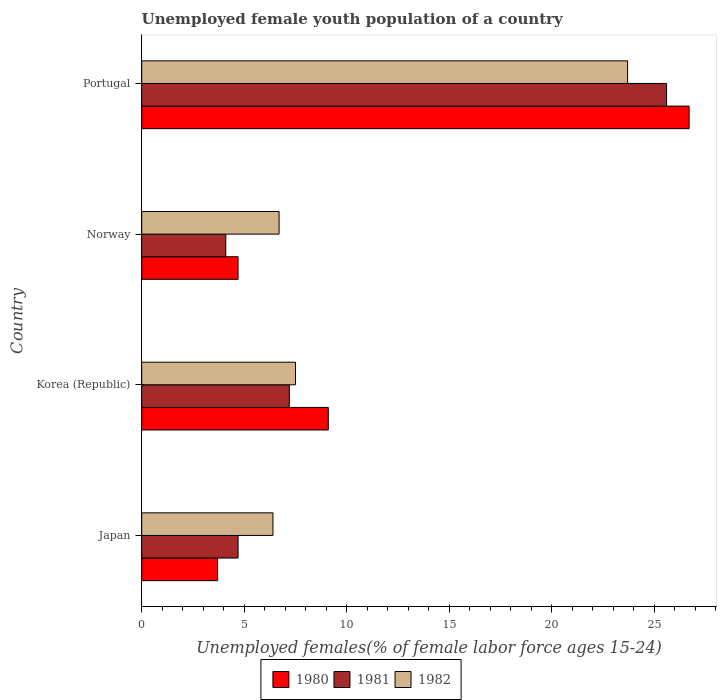How many different coloured bars are there?
Your response must be concise. 3. How many groups of bars are there?
Provide a succinct answer. 4. Are the number of bars on each tick of the Y-axis equal?
Make the answer very short. Yes. How many bars are there on the 2nd tick from the top?
Offer a very short reply. 3. How many bars are there on the 3rd tick from the bottom?
Ensure brevity in your answer.  3. What is the label of the 3rd group of bars from the top?
Give a very brief answer. Korea (Republic). In how many cases, is the number of bars for a given country not equal to the number of legend labels?
Give a very brief answer. 0. What is the percentage of unemployed female youth population in 1982 in Norway?
Your response must be concise. 6.7. Across all countries, what is the maximum percentage of unemployed female youth population in 1980?
Offer a very short reply. 26.7. Across all countries, what is the minimum percentage of unemployed female youth population in 1982?
Offer a very short reply. 6.4. In which country was the percentage of unemployed female youth population in 1980 maximum?
Keep it short and to the point. Portugal. What is the total percentage of unemployed female youth population in 1980 in the graph?
Give a very brief answer. 44.2. What is the difference between the percentage of unemployed female youth population in 1980 in Japan and that in Portugal?
Offer a terse response. -23. What is the difference between the percentage of unemployed female youth population in 1982 in Japan and the percentage of unemployed female youth population in 1980 in Norway?
Give a very brief answer. 1.7. What is the average percentage of unemployed female youth population in 1980 per country?
Provide a short and direct response. 11.05. What is the difference between the percentage of unemployed female youth population in 1981 and percentage of unemployed female youth population in 1980 in Japan?
Make the answer very short. 1. In how many countries, is the percentage of unemployed female youth population in 1980 greater than 5 %?
Provide a succinct answer. 2. What is the ratio of the percentage of unemployed female youth population in 1980 in Korea (Republic) to that in Portugal?
Keep it short and to the point. 0.34. Is the percentage of unemployed female youth population in 1982 in Korea (Republic) less than that in Portugal?
Provide a short and direct response. Yes. Is the difference between the percentage of unemployed female youth population in 1981 in Japan and Norway greater than the difference between the percentage of unemployed female youth population in 1980 in Japan and Norway?
Offer a terse response. Yes. What is the difference between the highest and the second highest percentage of unemployed female youth population in 1982?
Your answer should be very brief. 16.2. What is the difference between the highest and the lowest percentage of unemployed female youth population in 1980?
Offer a terse response. 23. Is the sum of the percentage of unemployed female youth population in 1981 in Norway and Portugal greater than the maximum percentage of unemployed female youth population in 1980 across all countries?
Offer a very short reply. Yes. What does the 3rd bar from the bottom in Korea (Republic) represents?
Your answer should be compact. 1982. How many countries are there in the graph?
Give a very brief answer. 4. Does the graph contain grids?
Provide a short and direct response. No. What is the title of the graph?
Provide a succinct answer. Unemployed female youth population of a country. Does "1975" appear as one of the legend labels in the graph?
Provide a succinct answer. No. What is the label or title of the X-axis?
Offer a terse response. Unemployed females(% of female labor force ages 15-24). What is the Unemployed females(% of female labor force ages 15-24) in 1980 in Japan?
Your response must be concise. 3.7. What is the Unemployed females(% of female labor force ages 15-24) of 1981 in Japan?
Offer a very short reply. 4.7. What is the Unemployed females(% of female labor force ages 15-24) in 1982 in Japan?
Your response must be concise. 6.4. What is the Unemployed females(% of female labor force ages 15-24) of 1980 in Korea (Republic)?
Make the answer very short. 9.1. What is the Unemployed females(% of female labor force ages 15-24) in 1981 in Korea (Republic)?
Your answer should be compact. 7.2. What is the Unemployed females(% of female labor force ages 15-24) in 1982 in Korea (Republic)?
Your response must be concise. 7.5. What is the Unemployed females(% of female labor force ages 15-24) of 1980 in Norway?
Your answer should be compact. 4.7. What is the Unemployed females(% of female labor force ages 15-24) in 1981 in Norway?
Provide a short and direct response. 4.1. What is the Unemployed females(% of female labor force ages 15-24) of 1982 in Norway?
Provide a short and direct response. 6.7. What is the Unemployed females(% of female labor force ages 15-24) in 1980 in Portugal?
Your response must be concise. 26.7. What is the Unemployed females(% of female labor force ages 15-24) in 1981 in Portugal?
Offer a terse response. 25.6. What is the Unemployed females(% of female labor force ages 15-24) of 1982 in Portugal?
Ensure brevity in your answer.  23.7. Across all countries, what is the maximum Unemployed females(% of female labor force ages 15-24) of 1980?
Provide a short and direct response. 26.7. Across all countries, what is the maximum Unemployed females(% of female labor force ages 15-24) in 1981?
Your answer should be very brief. 25.6. Across all countries, what is the maximum Unemployed females(% of female labor force ages 15-24) in 1982?
Your response must be concise. 23.7. Across all countries, what is the minimum Unemployed females(% of female labor force ages 15-24) of 1980?
Give a very brief answer. 3.7. Across all countries, what is the minimum Unemployed females(% of female labor force ages 15-24) in 1981?
Your response must be concise. 4.1. Across all countries, what is the minimum Unemployed females(% of female labor force ages 15-24) of 1982?
Provide a short and direct response. 6.4. What is the total Unemployed females(% of female labor force ages 15-24) of 1980 in the graph?
Offer a terse response. 44.2. What is the total Unemployed females(% of female labor force ages 15-24) in 1981 in the graph?
Your answer should be compact. 41.6. What is the total Unemployed females(% of female labor force ages 15-24) in 1982 in the graph?
Make the answer very short. 44.3. What is the difference between the Unemployed females(% of female labor force ages 15-24) of 1980 in Japan and that in Korea (Republic)?
Your response must be concise. -5.4. What is the difference between the Unemployed females(% of female labor force ages 15-24) of 1982 in Japan and that in Korea (Republic)?
Provide a short and direct response. -1.1. What is the difference between the Unemployed females(% of female labor force ages 15-24) in 1981 in Japan and that in Norway?
Keep it short and to the point. 0.6. What is the difference between the Unemployed females(% of female labor force ages 15-24) in 1981 in Japan and that in Portugal?
Offer a terse response. -20.9. What is the difference between the Unemployed females(% of female labor force ages 15-24) of 1982 in Japan and that in Portugal?
Keep it short and to the point. -17.3. What is the difference between the Unemployed females(% of female labor force ages 15-24) of 1980 in Korea (Republic) and that in Portugal?
Your answer should be very brief. -17.6. What is the difference between the Unemployed females(% of female labor force ages 15-24) in 1981 in Korea (Republic) and that in Portugal?
Provide a short and direct response. -18.4. What is the difference between the Unemployed females(% of female labor force ages 15-24) of 1982 in Korea (Republic) and that in Portugal?
Offer a very short reply. -16.2. What is the difference between the Unemployed females(% of female labor force ages 15-24) of 1980 in Norway and that in Portugal?
Provide a short and direct response. -22. What is the difference between the Unemployed females(% of female labor force ages 15-24) in 1981 in Norway and that in Portugal?
Make the answer very short. -21.5. What is the difference between the Unemployed females(% of female labor force ages 15-24) in 1982 in Norway and that in Portugal?
Ensure brevity in your answer.  -17. What is the difference between the Unemployed females(% of female labor force ages 15-24) in 1980 in Japan and the Unemployed females(% of female labor force ages 15-24) in 1982 in Korea (Republic)?
Offer a terse response. -3.8. What is the difference between the Unemployed females(% of female labor force ages 15-24) in 1981 in Japan and the Unemployed females(% of female labor force ages 15-24) in 1982 in Norway?
Offer a very short reply. -2. What is the difference between the Unemployed females(% of female labor force ages 15-24) of 1980 in Japan and the Unemployed females(% of female labor force ages 15-24) of 1981 in Portugal?
Give a very brief answer. -21.9. What is the difference between the Unemployed females(% of female labor force ages 15-24) in 1980 in Japan and the Unemployed females(% of female labor force ages 15-24) in 1982 in Portugal?
Give a very brief answer. -20. What is the difference between the Unemployed females(% of female labor force ages 15-24) in 1981 in Korea (Republic) and the Unemployed females(% of female labor force ages 15-24) in 1982 in Norway?
Give a very brief answer. 0.5. What is the difference between the Unemployed females(% of female labor force ages 15-24) in 1980 in Korea (Republic) and the Unemployed females(% of female labor force ages 15-24) in 1981 in Portugal?
Your response must be concise. -16.5. What is the difference between the Unemployed females(% of female labor force ages 15-24) in 1980 in Korea (Republic) and the Unemployed females(% of female labor force ages 15-24) in 1982 in Portugal?
Your answer should be compact. -14.6. What is the difference between the Unemployed females(% of female labor force ages 15-24) of 1981 in Korea (Republic) and the Unemployed females(% of female labor force ages 15-24) of 1982 in Portugal?
Offer a very short reply. -16.5. What is the difference between the Unemployed females(% of female labor force ages 15-24) of 1980 in Norway and the Unemployed females(% of female labor force ages 15-24) of 1981 in Portugal?
Offer a terse response. -20.9. What is the difference between the Unemployed females(% of female labor force ages 15-24) in 1980 in Norway and the Unemployed females(% of female labor force ages 15-24) in 1982 in Portugal?
Offer a terse response. -19. What is the difference between the Unemployed females(% of female labor force ages 15-24) of 1981 in Norway and the Unemployed females(% of female labor force ages 15-24) of 1982 in Portugal?
Ensure brevity in your answer.  -19.6. What is the average Unemployed females(% of female labor force ages 15-24) in 1980 per country?
Your response must be concise. 11.05. What is the average Unemployed females(% of female labor force ages 15-24) of 1981 per country?
Your answer should be compact. 10.4. What is the average Unemployed females(% of female labor force ages 15-24) in 1982 per country?
Your answer should be very brief. 11.07. What is the difference between the Unemployed females(% of female labor force ages 15-24) in 1980 and Unemployed females(% of female labor force ages 15-24) in 1981 in Japan?
Provide a succinct answer. -1. What is the difference between the Unemployed females(% of female labor force ages 15-24) of 1980 and Unemployed females(% of female labor force ages 15-24) of 1982 in Japan?
Your answer should be compact. -2.7. What is the difference between the Unemployed females(% of female labor force ages 15-24) of 1981 and Unemployed females(% of female labor force ages 15-24) of 1982 in Japan?
Offer a very short reply. -1.7. What is the difference between the Unemployed females(% of female labor force ages 15-24) in 1980 and Unemployed females(% of female labor force ages 15-24) in 1981 in Korea (Republic)?
Give a very brief answer. 1.9. What is the difference between the Unemployed females(% of female labor force ages 15-24) of 1980 and Unemployed females(% of female labor force ages 15-24) of 1982 in Korea (Republic)?
Offer a terse response. 1.6. What is the difference between the Unemployed females(% of female labor force ages 15-24) of 1981 and Unemployed females(% of female labor force ages 15-24) of 1982 in Korea (Republic)?
Keep it short and to the point. -0.3. What is the difference between the Unemployed females(% of female labor force ages 15-24) of 1980 and Unemployed females(% of female labor force ages 15-24) of 1981 in Portugal?
Your response must be concise. 1.1. What is the difference between the Unemployed females(% of female labor force ages 15-24) of 1980 and Unemployed females(% of female labor force ages 15-24) of 1982 in Portugal?
Offer a very short reply. 3. What is the ratio of the Unemployed females(% of female labor force ages 15-24) of 1980 in Japan to that in Korea (Republic)?
Provide a short and direct response. 0.41. What is the ratio of the Unemployed females(% of female labor force ages 15-24) of 1981 in Japan to that in Korea (Republic)?
Make the answer very short. 0.65. What is the ratio of the Unemployed females(% of female labor force ages 15-24) of 1982 in Japan to that in Korea (Republic)?
Provide a succinct answer. 0.85. What is the ratio of the Unemployed females(% of female labor force ages 15-24) in 1980 in Japan to that in Norway?
Offer a very short reply. 0.79. What is the ratio of the Unemployed females(% of female labor force ages 15-24) in 1981 in Japan to that in Norway?
Your answer should be very brief. 1.15. What is the ratio of the Unemployed females(% of female labor force ages 15-24) of 1982 in Japan to that in Norway?
Make the answer very short. 0.96. What is the ratio of the Unemployed females(% of female labor force ages 15-24) of 1980 in Japan to that in Portugal?
Ensure brevity in your answer.  0.14. What is the ratio of the Unemployed females(% of female labor force ages 15-24) in 1981 in Japan to that in Portugal?
Your answer should be compact. 0.18. What is the ratio of the Unemployed females(% of female labor force ages 15-24) of 1982 in Japan to that in Portugal?
Provide a succinct answer. 0.27. What is the ratio of the Unemployed females(% of female labor force ages 15-24) in 1980 in Korea (Republic) to that in Norway?
Provide a succinct answer. 1.94. What is the ratio of the Unemployed females(% of female labor force ages 15-24) of 1981 in Korea (Republic) to that in Norway?
Provide a short and direct response. 1.76. What is the ratio of the Unemployed females(% of female labor force ages 15-24) of 1982 in Korea (Republic) to that in Norway?
Offer a very short reply. 1.12. What is the ratio of the Unemployed females(% of female labor force ages 15-24) of 1980 in Korea (Republic) to that in Portugal?
Give a very brief answer. 0.34. What is the ratio of the Unemployed females(% of female labor force ages 15-24) of 1981 in Korea (Republic) to that in Portugal?
Keep it short and to the point. 0.28. What is the ratio of the Unemployed females(% of female labor force ages 15-24) of 1982 in Korea (Republic) to that in Portugal?
Provide a succinct answer. 0.32. What is the ratio of the Unemployed females(% of female labor force ages 15-24) of 1980 in Norway to that in Portugal?
Provide a short and direct response. 0.18. What is the ratio of the Unemployed females(% of female labor force ages 15-24) of 1981 in Norway to that in Portugal?
Offer a terse response. 0.16. What is the ratio of the Unemployed females(% of female labor force ages 15-24) of 1982 in Norway to that in Portugal?
Your answer should be very brief. 0.28. What is the difference between the highest and the lowest Unemployed females(% of female labor force ages 15-24) in 1980?
Ensure brevity in your answer.  23. 